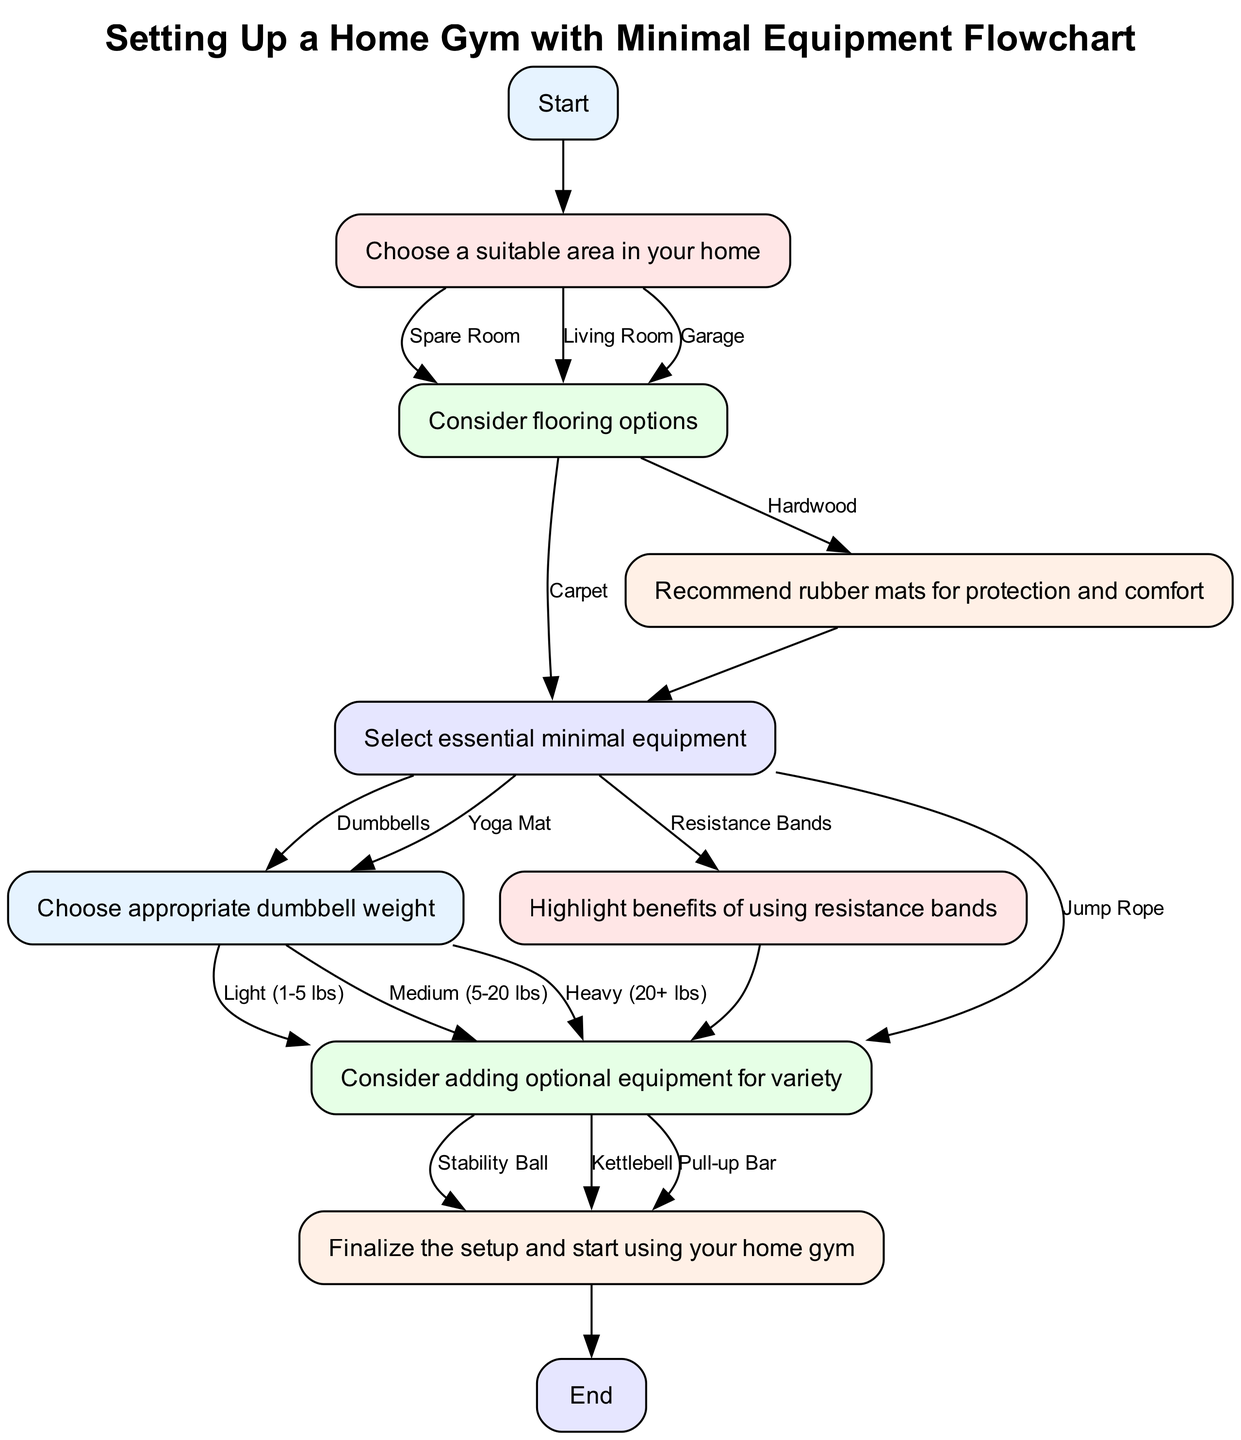What is the starting point of the flowchart? The flowchart begins at the node labeled "Start", which is the initial step for setting up a home gym.
Answer: Start How many options are available for choosing the area in your home? In the "Choose a suitable area in your home" step, there are three options: Spare Room, Living Room, and Garage. Hence, the total options are counted; the answer is three.
Answer: Three What flooring option follows the choice of hardwood? Choosing hardwood leads to the recommendation of rubber mats for protection and comfort, detailing the benefits of flooring options before moving on to equipment selection.
Answer: Recommend rubber mats for protection and comfort Which equipment option leads to choosing dumbbell weight? The equipment selection step shows that both Dumbbells and Yoga Mat lead to choosing their respective dumbbell weights, hence the answer reflects both items that follow in the flow.
Answer: Dumbbells, Yoga Mat How many pieces of optional equipment can be considered for variety? The "Consider adding optional equipment for variety" step provides three options: Stability Ball, Kettlebell, and Pull-up Bar, amounting to a total of three different optional pieces of equipment.
Answer: Three What step comes after selecting appropriate dumbbell weight? After the selection of dumbbell weight, the next step is to consider adding optional equipment, denoting a transition from weight consideration to enhancing the gym setup.
Answer: Consider adding optional equipment for variety What is the last step of the flowchart? The final step of the flowchart is "Finalize the setup and start using your home gym," indicating the completion of the home gym setup process before reaching the end.
Answer: Finalize the setup and start using your home gym What are the three flooring options available in the flowchart? The options provided in the "Consider flooring options" step are: Carpet and Hardwood. These two are directly mentioned, while a recommendation for mats follows associated with hardwood.
Answer: Carpet, Hardwood 